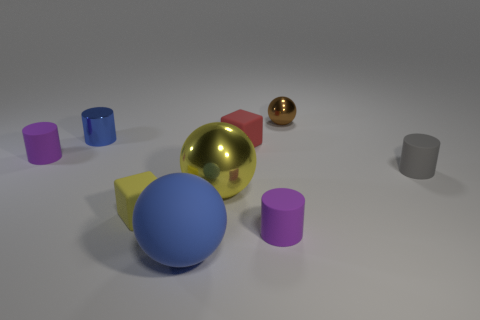What number of objects are either tiny matte objects on the left side of the brown object or blue things in front of the gray matte cylinder?
Offer a terse response. 5. How many brown objects have the same shape as the small blue shiny object?
Offer a very short reply. 0. What is the color of the metallic ball that is the same size as the red matte thing?
Keep it short and to the point. Brown. There is a matte cylinder that is behind the rubber object that is to the right of the ball that is behind the tiny gray matte cylinder; what is its color?
Make the answer very short. Purple. There is a matte sphere; does it have the same size as the purple matte cylinder to the left of the big yellow metal ball?
Your answer should be very brief. No. What number of objects are either gray matte objects or large objects?
Give a very brief answer. 3. Is there a big brown ball that has the same material as the tiny blue object?
Provide a short and direct response. No. There is a sphere that is the same color as the shiny cylinder; what is its size?
Offer a terse response. Large. There is a rubber block behind the yellow object that is left of the rubber sphere; what is its color?
Provide a short and direct response. Red. Does the brown metal ball have the same size as the yellow shiny ball?
Your answer should be very brief. No. 